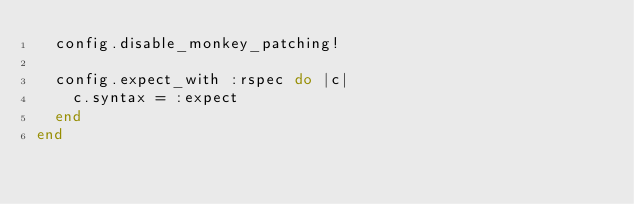<code> <loc_0><loc_0><loc_500><loc_500><_Ruby_>  config.disable_monkey_patching!

  config.expect_with :rspec do |c|
    c.syntax = :expect
  end
end
</code> 